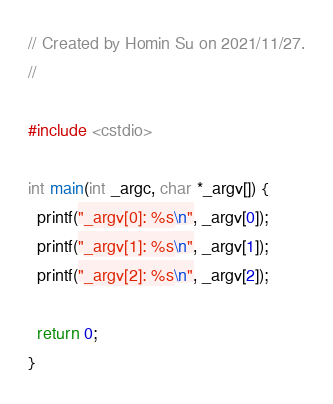Convert code to text. <code><loc_0><loc_0><loc_500><loc_500><_C++_>// Created by Homin Su on 2021/11/27.
//

#include <cstdio>

int main(int _argc, char *_argv[]) {
  printf("_argv[0]: %s\n", _argv[0]);
  printf("_argv[1]: %s\n", _argv[1]);
  printf("_argv[2]: %s\n", _argv[2]);

  return 0;
}

</code> 